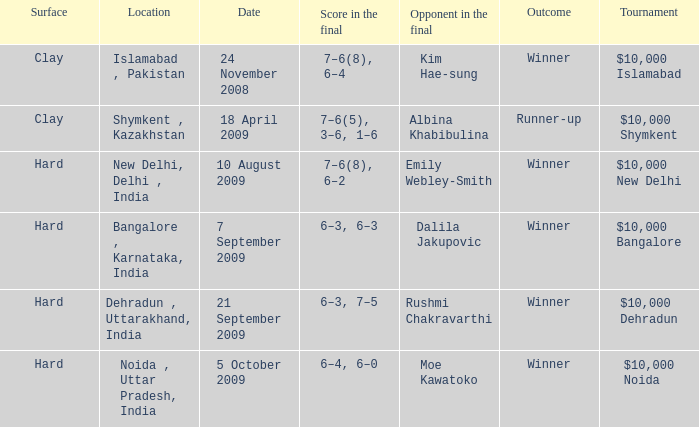What is the name of the tournament where outcome is runner-up $10,000 Shymkent. Could you parse the entire table? {'header': ['Surface', 'Location', 'Date', 'Score in the final', 'Opponent in the final', 'Outcome', 'Tournament'], 'rows': [['Clay', 'Islamabad , Pakistan', '24 November 2008', '7–6(8), 6–4', 'Kim Hae-sung', 'Winner', '$10,000 Islamabad'], ['Clay', 'Shymkent , Kazakhstan', '18 April 2009', '7–6(5), 3–6, 1–6', 'Albina Khabibulina', 'Runner-up', '$10,000 Shymkent'], ['Hard', 'New Delhi, Delhi , India', '10 August 2009', '7–6(8), 6–2', 'Emily Webley-Smith', 'Winner', '$10,000 New Delhi'], ['Hard', 'Bangalore , Karnataka, India', '7 September 2009', '6–3, 6–3', 'Dalila Jakupovic', 'Winner', '$10,000 Bangalore'], ['Hard', 'Dehradun , Uttarakhand, India', '21 September 2009', '6–3, 7–5', 'Rushmi Chakravarthi', 'Winner', '$10,000 Dehradun'], ['Hard', 'Noida , Uttar Pradesh, India', '5 October 2009', '6–4, 6–0', 'Moe Kawatoko', 'Winner', '$10,000 Noida']]} 